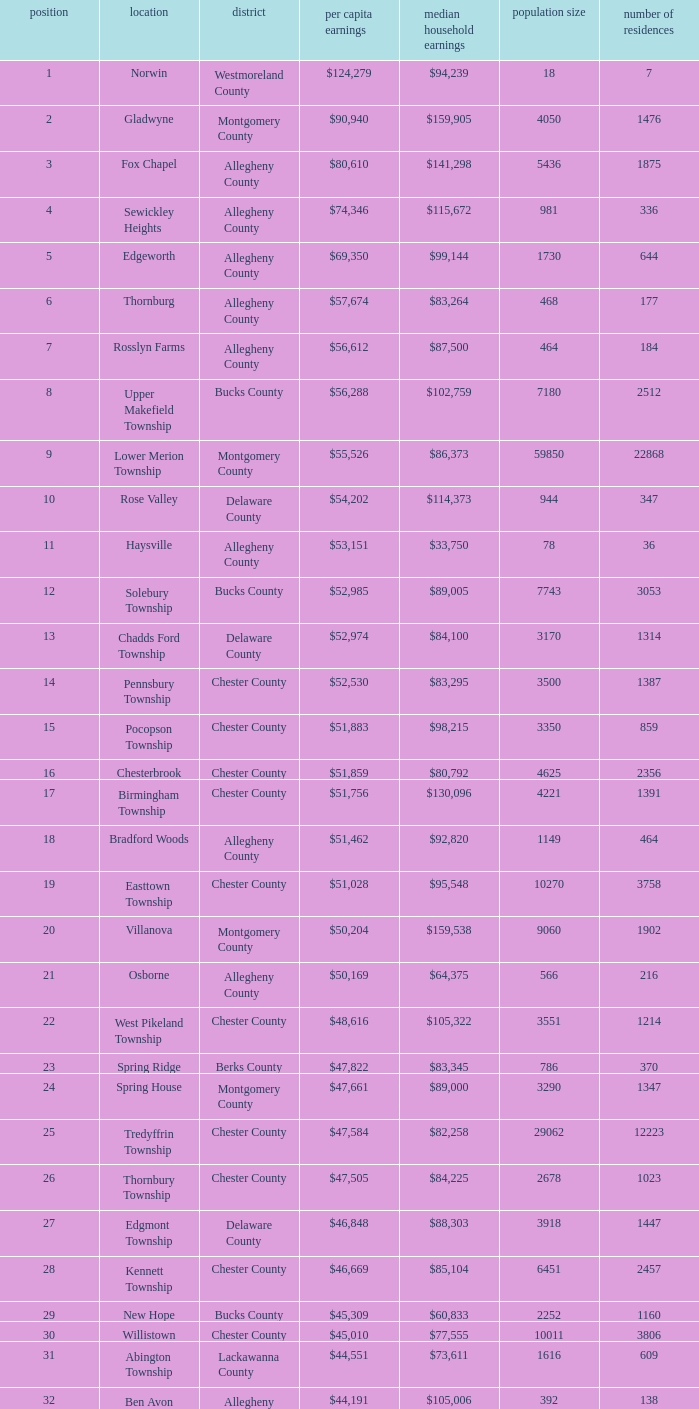Which county has a median household income of  $98,090? Bucks County. 